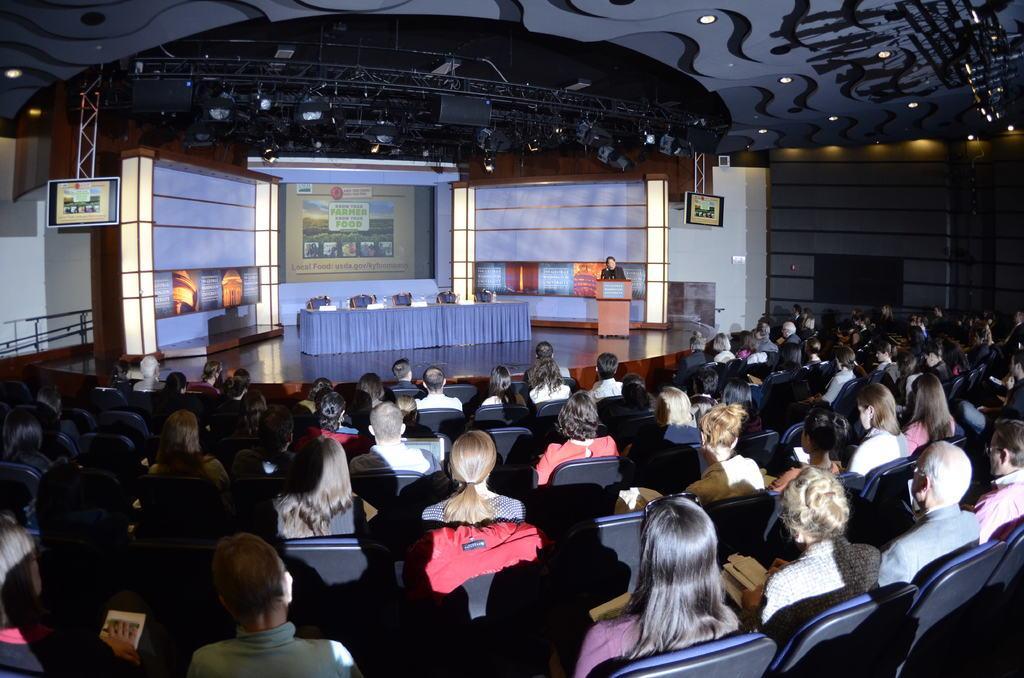Please provide a concise description of this image. In this image we can see some people sitting on chairs and there is a person standing on the stage and there is a podium in front of him and we can see some chairs and a table on the stage. In the background we can see a screen with some pictures and there are some stage lights and there are two television screens are attached at the top. 